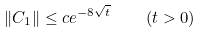Convert formula to latex. <formula><loc_0><loc_0><loc_500><loc_500>\| C _ { 1 } \| \leq c e ^ { - 8 \sqrt { t } } \quad ( t > 0 )</formula> 